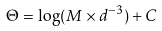<formula> <loc_0><loc_0><loc_500><loc_500>\Theta = \log ( M \times d ^ { - 3 } ) + C</formula> 